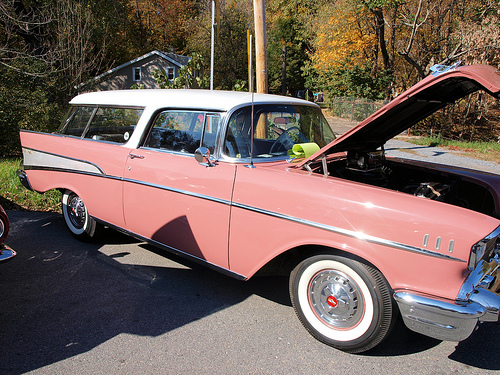<image>
Is there a wheel in front of the car? No. The wheel is not in front of the car. The spatial positioning shows a different relationship between these objects. 